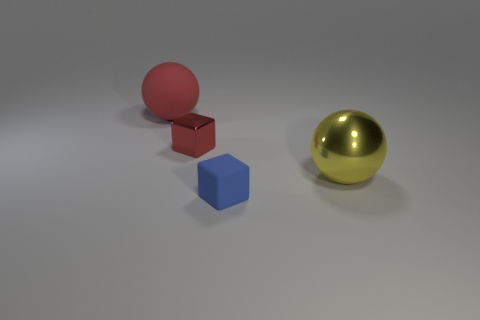The ball that is the same color as the tiny metallic thing is what size?
Make the answer very short. Large. There is a large ball right of the block that is in front of the tiny red metallic object; what color is it?
Ensure brevity in your answer.  Yellow. Is there a small metal cube that has the same color as the small matte block?
Give a very brief answer. No. How many metallic objects are either blue cubes or gray cylinders?
Provide a succinct answer. 0. Is there a red ball made of the same material as the blue cube?
Your answer should be compact. Yes. How many objects are behind the blue matte cube and in front of the red metallic thing?
Your response must be concise. 1. Are there fewer big metallic objects left of the tiny red cube than tiny rubber cubes that are on the right side of the large red thing?
Give a very brief answer. Yes. Is the tiny red metal thing the same shape as the red rubber thing?
Provide a succinct answer. No. What number of things are either cubes behind the big metal thing or small blue blocks that are left of the large yellow metal ball?
Your answer should be compact. 2. What number of big yellow things are the same shape as the tiny blue thing?
Keep it short and to the point. 0. 